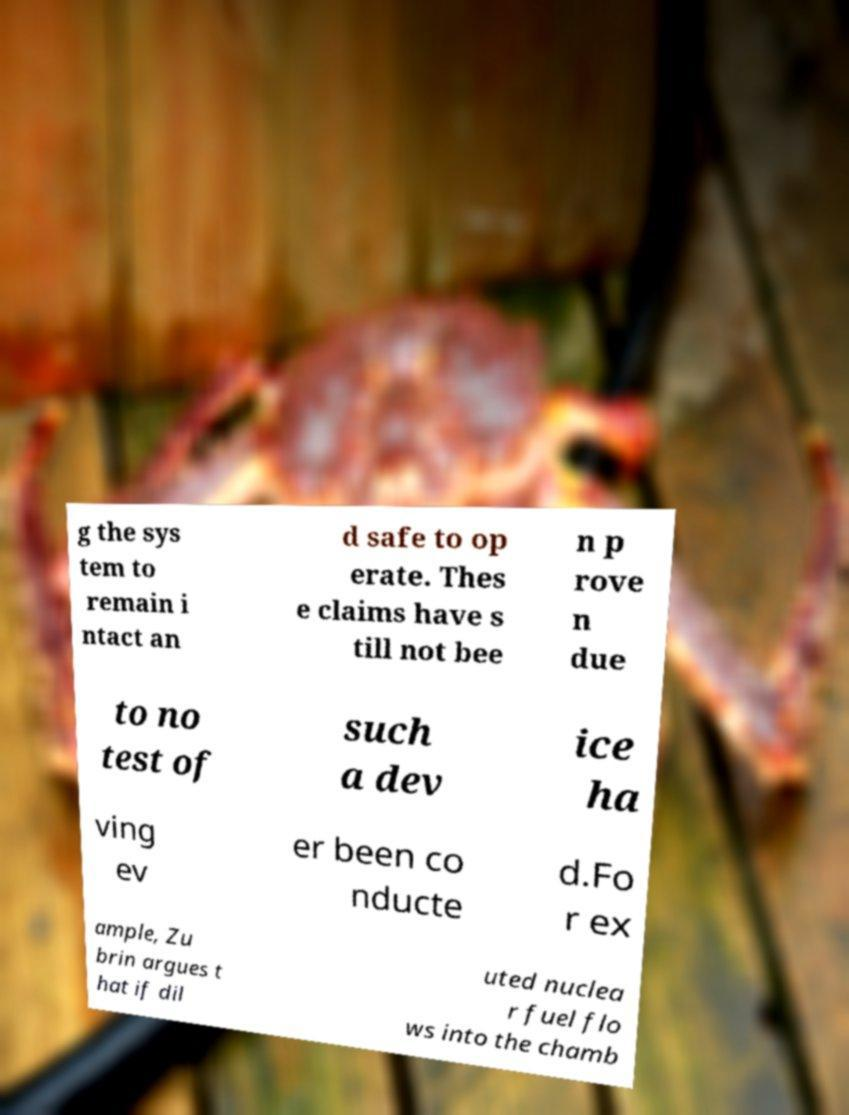I need the written content from this picture converted into text. Can you do that? g the sys tem to remain i ntact an d safe to op erate. Thes e claims have s till not bee n p rove n due to no test of such a dev ice ha ving ev er been co nducte d.Fo r ex ample, Zu brin argues t hat if dil uted nuclea r fuel flo ws into the chamb 